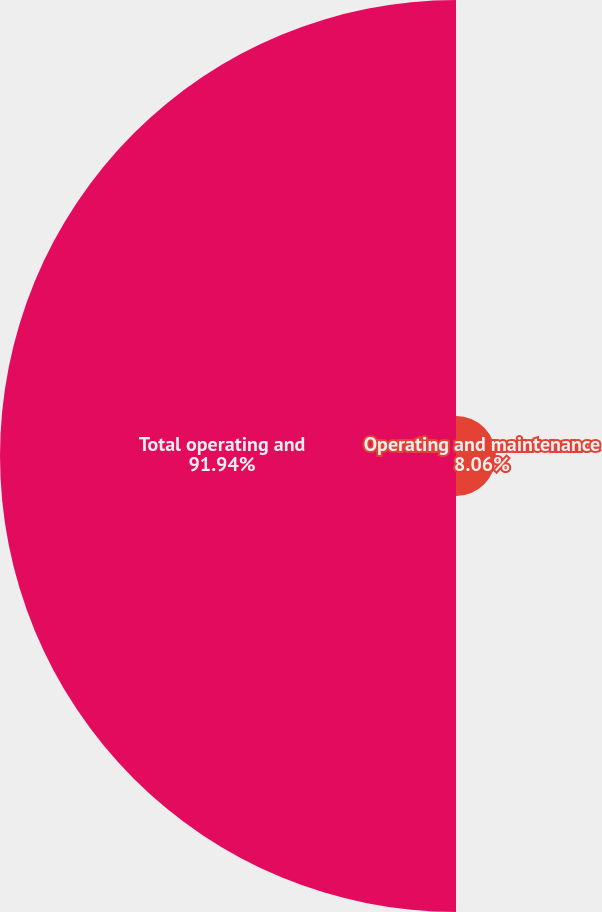<chart> <loc_0><loc_0><loc_500><loc_500><pie_chart><fcel>Operating and maintenance<fcel>Total operating and<nl><fcel>8.06%<fcel>91.94%<nl></chart> 